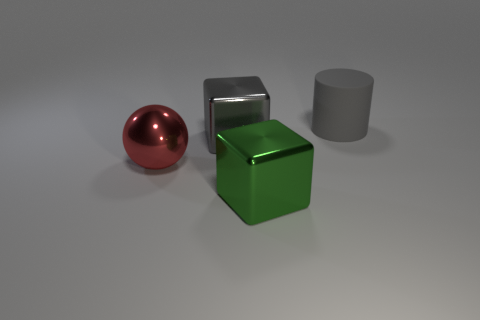Add 4 cylinders. How many objects exist? 8 Subtract 0 purple spheres. How many objects are left? 4 Subtract all cylinders. How many objects are left? 3 Subtract all big gray metal balls. Subtract all big cylinders. How many objects are left? 3 Add 4 gray matte cylinders. How many gray matte cylinders are left? 5 Add 4 gray rubber objects. How many gray rubber objects exist? 5 